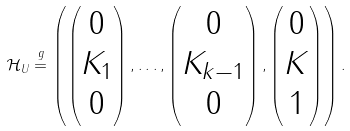Convert formula to latex. <formula><loc_0><loc_0><loc_500><loc_500>\mathcal { H } _ { U } \stackrel { g } { = } \left ( \begin{pmatrix} 0 \\ K _ { 1 } \\ 0 \end{pmatrix} , \dots , \begin{pmatrix} 0 \\ K _ { k - 1 } \\ 0 \end{pmatrix} , \begin{pmatrix} 0 \\ K \\ 1 \end{pmatrix} \right ) .</formula> 